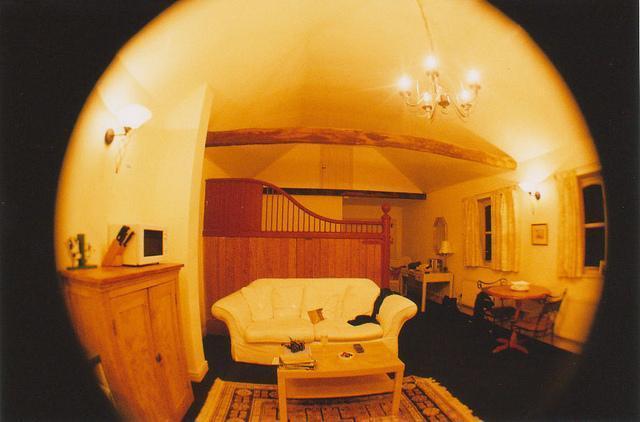How many tables are in this room?
Give a very brief answer. 3. How many windows are visible?
Give a very brief answer. 2. How many couches are visible?
Give a very brief answer. 1. 